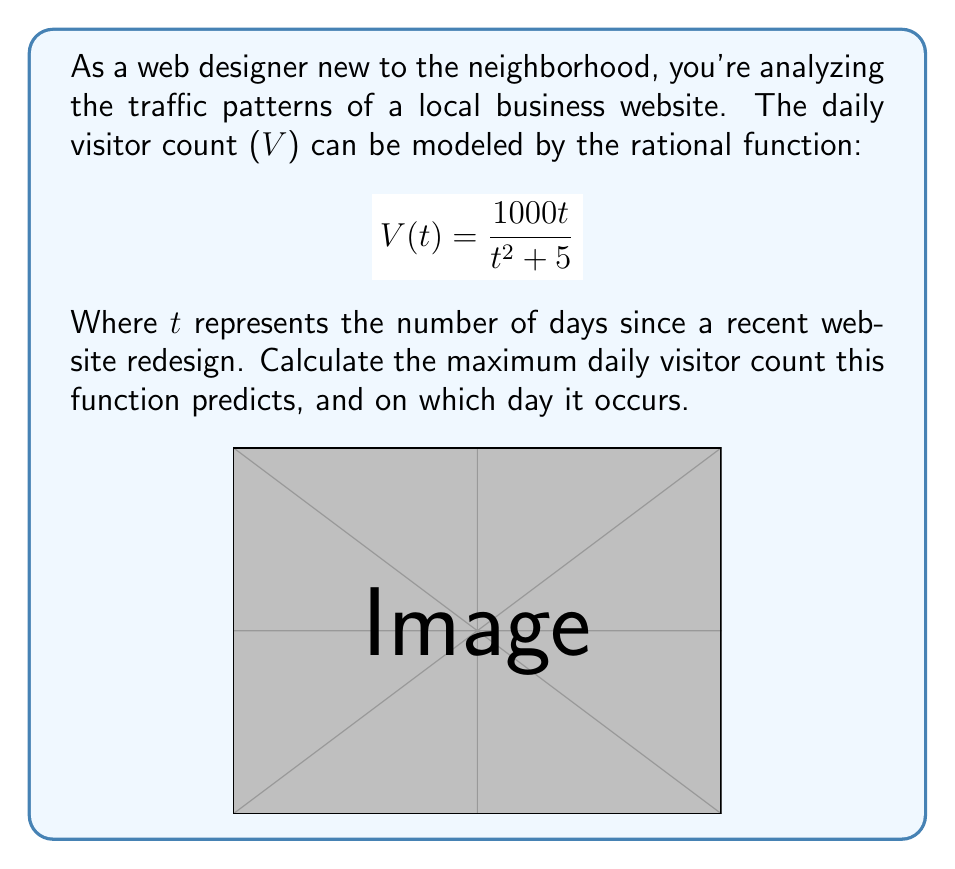Can you answer this question? To find the maximum value of the rational function and when it occurs, we'll follow these steps:

1) First, we need to find the critical points by taking the derivative of V(t) and setting it equal to zero.

2) Using the quotient rule, the derivative is:
   $$V'(t) = \frac{(t^2 + 5)(1000) - 1000t(2t)}{(t^2 + 5)^2}$$

3) Simplify:
   $$V'(t) = \frac{1000t^2 + 5000 - 2000t^2}{(t^2 + 5)^2} = \frac{5000 - 1000t^2}{(t^2 + 5)^2}$$

4) Set V'(t) = 0 and solve:
   $$\frac{5000 - 1000t^2}{(t^2 + 5)^2} = 0$$
   $$5000 - 1000t^2 = 0$$
   $$5000 = 1000t^2$$
   $$5 = t^2$$
   $$t = \sqrt{5} \approx 2.236$$

5) The critical point occurs at $t = \sqrt{5}$. To confirm this is a maximum, we could check the second derivative or observe that the function approaches 0 as t approaches infinity.

6) To find the maximum visitor count, plug $t = \sqrt{5}$ into the original function:

   $$V(\sqrt{5}) = \frac{1000\sqrt{5}}{(\sqrt{5})^2 + 5} = \frac{1000\sqrt{5}}{10} = 100\sqrt{5} \approx 223.6$$

Therefore, the maximum daily visitor count is $100\sqrt{5}$ (approximately 224 visitors), occurring on day $\sqrt{5}$ (approximately 2.24 days) after the redesign.
Answer: $100\sqrt{5}$ visitors on day $\sqrt{5}$ 